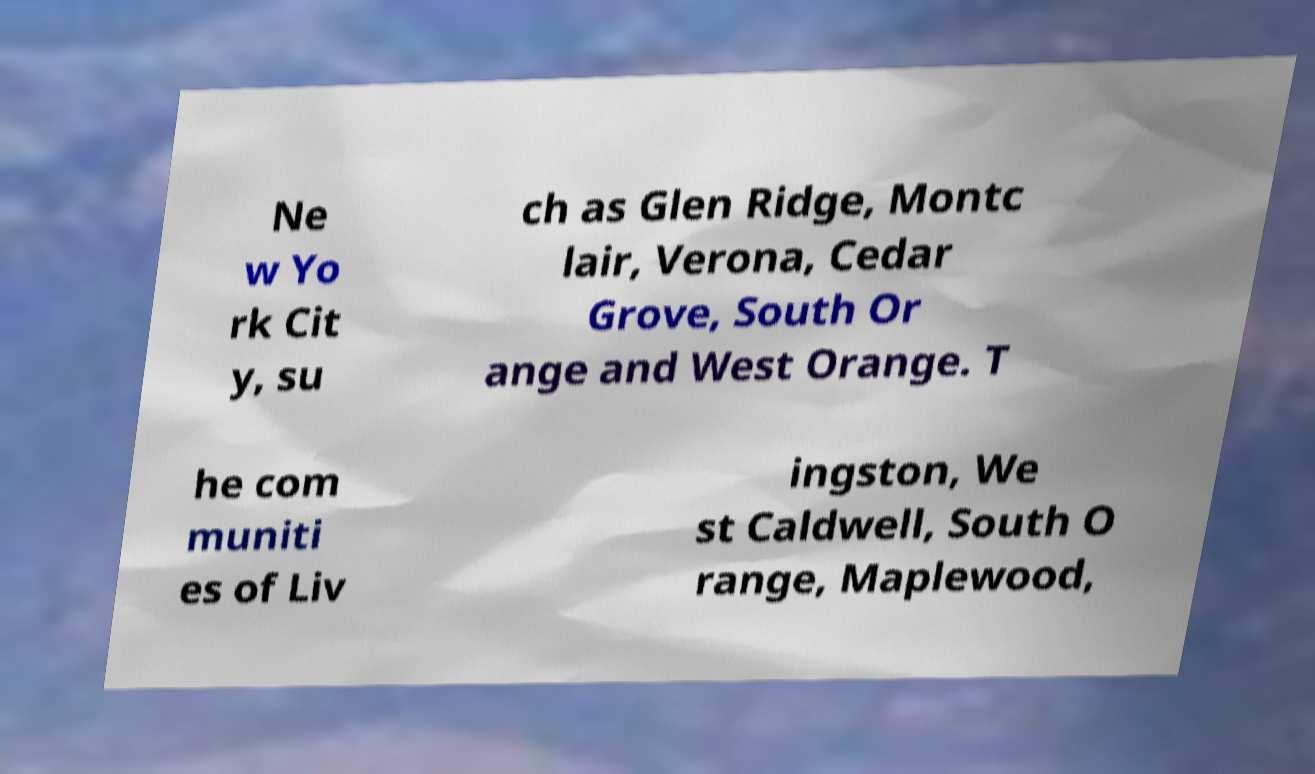I need the written content from this picture converted into text. Can you do that? Ne w Yo rk Cit y, su ch as Glen Ridge, Montc lair, Verona, Cedar Grove, South Or ange and West Orange. T he com muniti es of Liv ingston, We st Caldwell, South O range, Maplewood, 